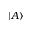<formula> <loc_0><loc_0><loc_500><loc_500>| A \rangle</formula> 